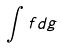Convert formula to latex. <formula><loc_0><loc_0><loc_500><loc_500>\int f d g</formula> 